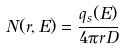<formula> <loc_0><loc_0><loc_500><loc_500>N ( r , E ) = \frac { q _ { s } ( E ) } { 4 \pi r D }</formula> 